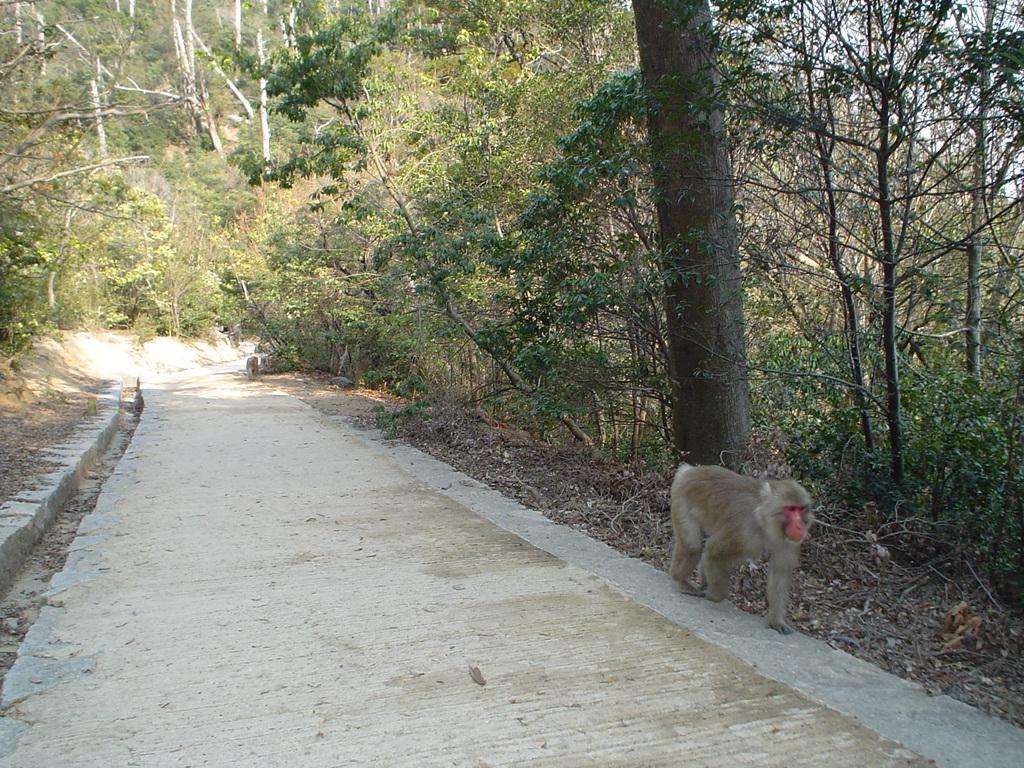How would you summarize this image in a sentence or two? In this image, we can see a monkey on the road and in the background, there are trees. 